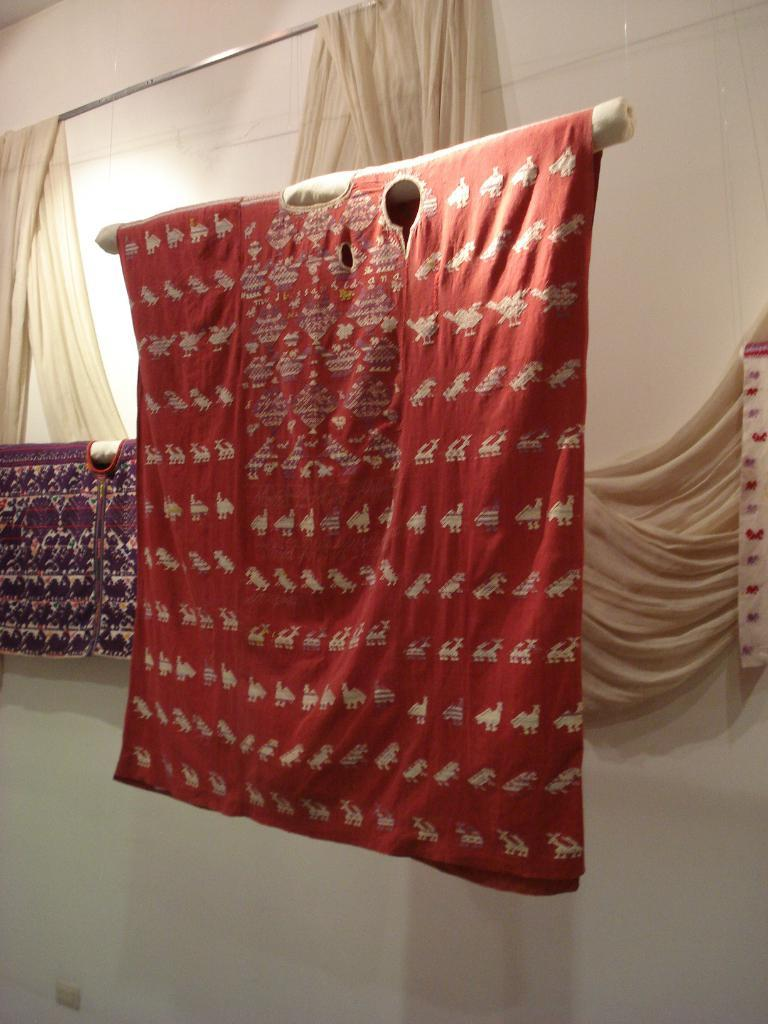What objects are located in the center of the image? There are hangers and curtains in the center of the image. Can you describe the background of the image? There is a wall in the background of the image. Is the snake in the image trying to climb the hangers? There is no snake present in the image. 